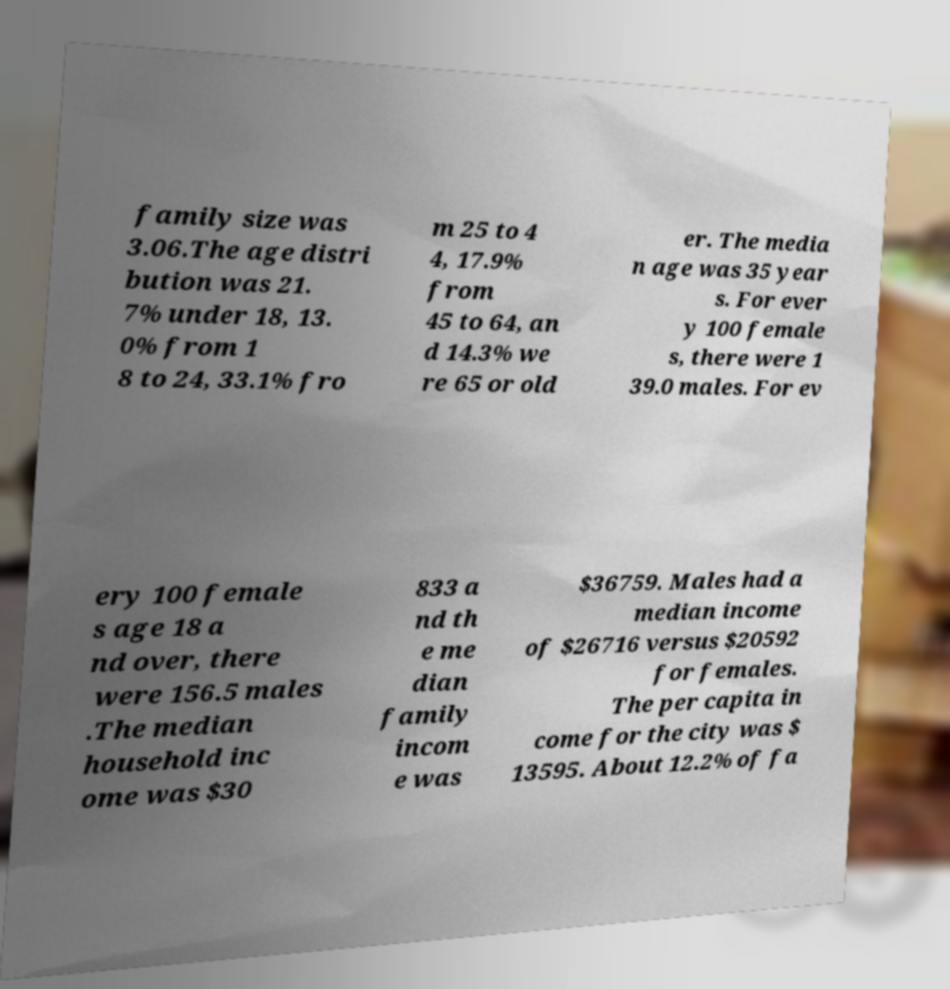What messages or text are displayed in this image? I need them in a readable, typed format. family size was 3.06.The age distri bution was 21. 7% under 18, 13. 0% from 1 8 to 24, 33.1% fro m 25 to 4 4, 17.9% from 45 to 64, an d 14.3% we re 65 or old er. The media n age was 35 year s. For ever y 100 female s, there were 1 39.0 males. For ev ery 100 female s age 18 a nd over, there were 156.5 males .The median household inc ome was $30 833 a nd th e me dian family incom e was $36759. Males had a median income of $26716 versus $20592 for females. The per capita in come for the city was $ 13595. About 12.2% of fa 